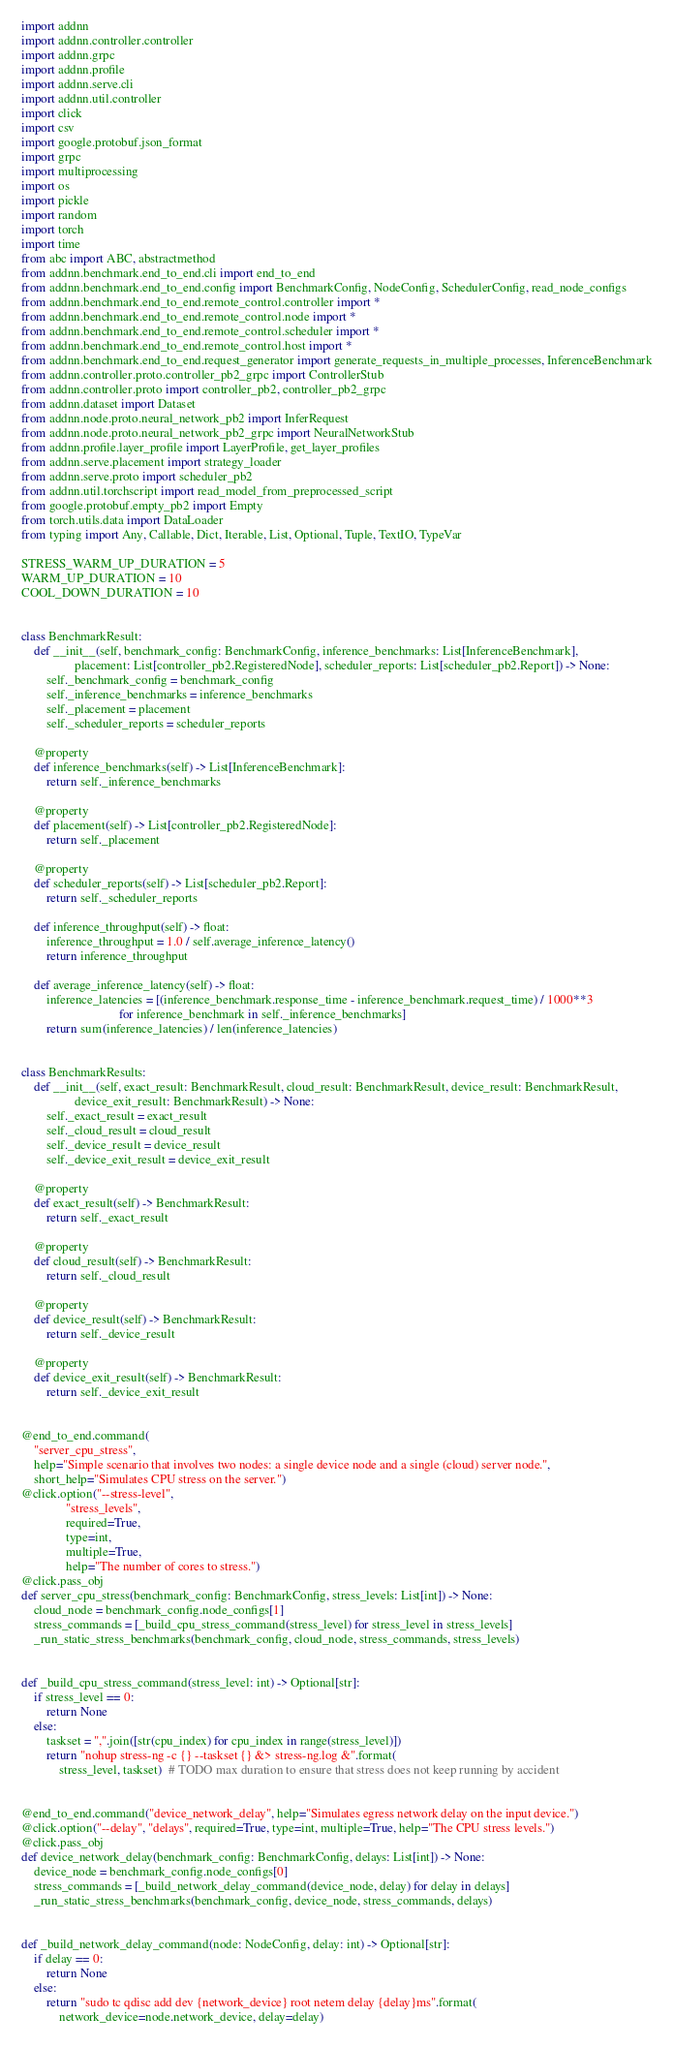<code> <loc_0><loc_0><loc_500><loc_500><_Python_>import addnn
import addnn.controller.controller
import addnn.grpc
import addnn.profile
import addnn.serve.cli
import addnn.util.controller
import click
import csv
import google.protobuf.json_format
import grpc
import multiprocessing
import os
import pickle
import random
import torch
import time
from abc import ABC, abstractmethod
from addnn.benchmark.end_to_end.cli import end_to_end
from addnn.benchmark.end_to_end.config import BenchmarkConfig, NodeConfig, SchedulerConfig, read_node_configs
from addnn.benchmark.end_to_end.remote_control.controller import *
from addnn.benchmark.end_to_end.remote_control.node import *
from addnn.benchmark.end_to_end.remote_control.scheduler import *
from addnn.benchmark.end_to_end.remote_control.host import *
from addnn.benchmark.end_to_end.request_generator import generate_requests_in_multiple_processes, InferenceBenchmark
from addnn.controller.proto.controller_pb2_grpc import ControllerStub
from addnn.controller.proto import controller_pb2, controller_pb2_grpc
from addnn.dataset import Dataset
from addnn.node.proto.neural_network_pb2 import InferRequest
from addnn.node.proto.neural_network_pb2_grpc import NeuralNetworkStub
from addnn.profile.layer_profile import LayerProfile, get_layer_profiles
from addnn.serve.placement import strategy_loader
from addnn.serve.proto import scheduler_pb2
from addnn.util.torchscript import read_model_from_preprocessed_script
from google.protobuf.empty_pb2 import Empty
from torch.utils.data import DataLoader
from typing import Any, Callable, Dict, Iterable, List, Optional, Tuple, TextIO, TypeVar

STRESS_WARM_UP_DURATION = 5
WARM_UP_DURATION = 10
COOL_DOWN_DURATION = 10


class BenchmarkResult:
    def __init__(self, benchmark_config: BenchmarkConfig, inference_benchmarks: List[InferenceBenchmark],
                 placement: List[controller_pb2.RegisteredNode], scheduler_reports: List[scheduler_pb2.Report]) -> None:
        self._benchmark_config = benchmark_config
        self._inference_benchmarks = inference_benchmarks
        self._placement = placement
        self._scheduler_reports = scheduler_reports

    @property
    def inference_benchmarks(self) -> List[InferenceBenchmark]:
        return self._inference_benchmarks

    @property
    def placement(self) -> List[controller_pb2.RegisteredNode]:
        return self._placement

    @property
    def scheduler_reports(self) -> List[scheduler_pb2.Report]:
        return self._scheduler_reports

    def inference_throughput(self) -> float:
        inference_throughput = 1.0 / self.average_inference_latency()
        return inference_throughput

    def average_inference_latency(self) -> float:
        inference_latencies = [(inference_benchmark.response_time - inference_benchmark.request_time) / 1000**3
                               for inference_benchmark in self._inference_benchmarks]
        return sum(inference_latencies) / len(inference_latencies)


class BenchmarkResults:
    def __init__(self, exact_result: BenchmarkResult, cloud_result: BenchmarkResult, device_result: BenchmarkResult,
                 device_exit_result: BenchmarkResult) -> None:
        self._exact_result = exact_result
        self._cloud_result = cloud_result
        self._device_result = device_result
        self._device_exit_result = device_exit_result

    @property
    def exact_result(self) -> BenchmarkResult:
        return self._exact_result

    @property
    def cloud_result(self) -> BenchmarkResult:
        return self._cloud_result

    @property
    def device_result(self) -> BenchmarkResult:
        return self._device_result

    @property
    def device_exit_result(self) -> BenchmarkResult:
        return self._device_exit_result


@end_to_end.command(
    "server_cpu_stress",
    help="Simple scenario that involves two nodes: a single device node and a single (cloud) server node.",
    short_help="Simulates CPU stress on the server.")
@click.option("--stress-level",
              "stress_levels",
              required=True,
              type=int,
              multiple=True,
              help="The number of cores to stress.")
@click.pass_obj
def server_cpu_stress(benchmark_config: BenchmarkConfig, stress_levels: List[int]) -> None:
    cloud_node = benchmark_config.node_configs[1]
    stress_commands = [_build_cpu_stress_command(stress_level) for stress_level in stress_levels]
    _run_static_stress_benchmarks(benchmark_config, cloud_node, stress_commands, stress_levels)


def _build_cpu_stress_command(stress_level: int) -> Optional[str]:
    if stress_level == 0:
        return None
    else:
        taskset = ",".join([str(cpu_index) for cpu_index in range(stress_level)])
        return "nohup stress-ng -c {} --taskset {} &> stress-ng.log &".format(
            stress_level, taskset)  # TODO max duration to ensure that stress does not keep running by accident


@end_to_end.command("device_network_delay", help="Simulates egress network delay on the input device.")
@click.option("--delay", "delays", required=True, type=int, multiple=True, help="The CPU stress levels.")
@click.pass_obj
def device_network_delay(benchmark_config: BenchmarkConfig, delays: List[int]) -> None:
    device_node = benchmark_config.node_configs[0]
    stress_commands = [_build_network_delay_command(device_node, delay) for delay in delays]
    _run_static_stress_benchmarks(benchmark_config, device_node, stress_commands, delays)


def _build_network_delay_command(node: NodeConfig, delay: int) -> Optional[str]:
    if delay == 0:
        return None
    else:
        return "sudo tc qdisc add dev {network_device} root netem delay {delay}ms".format(
            network_device=node.network_device, delay=delay)

</code> 